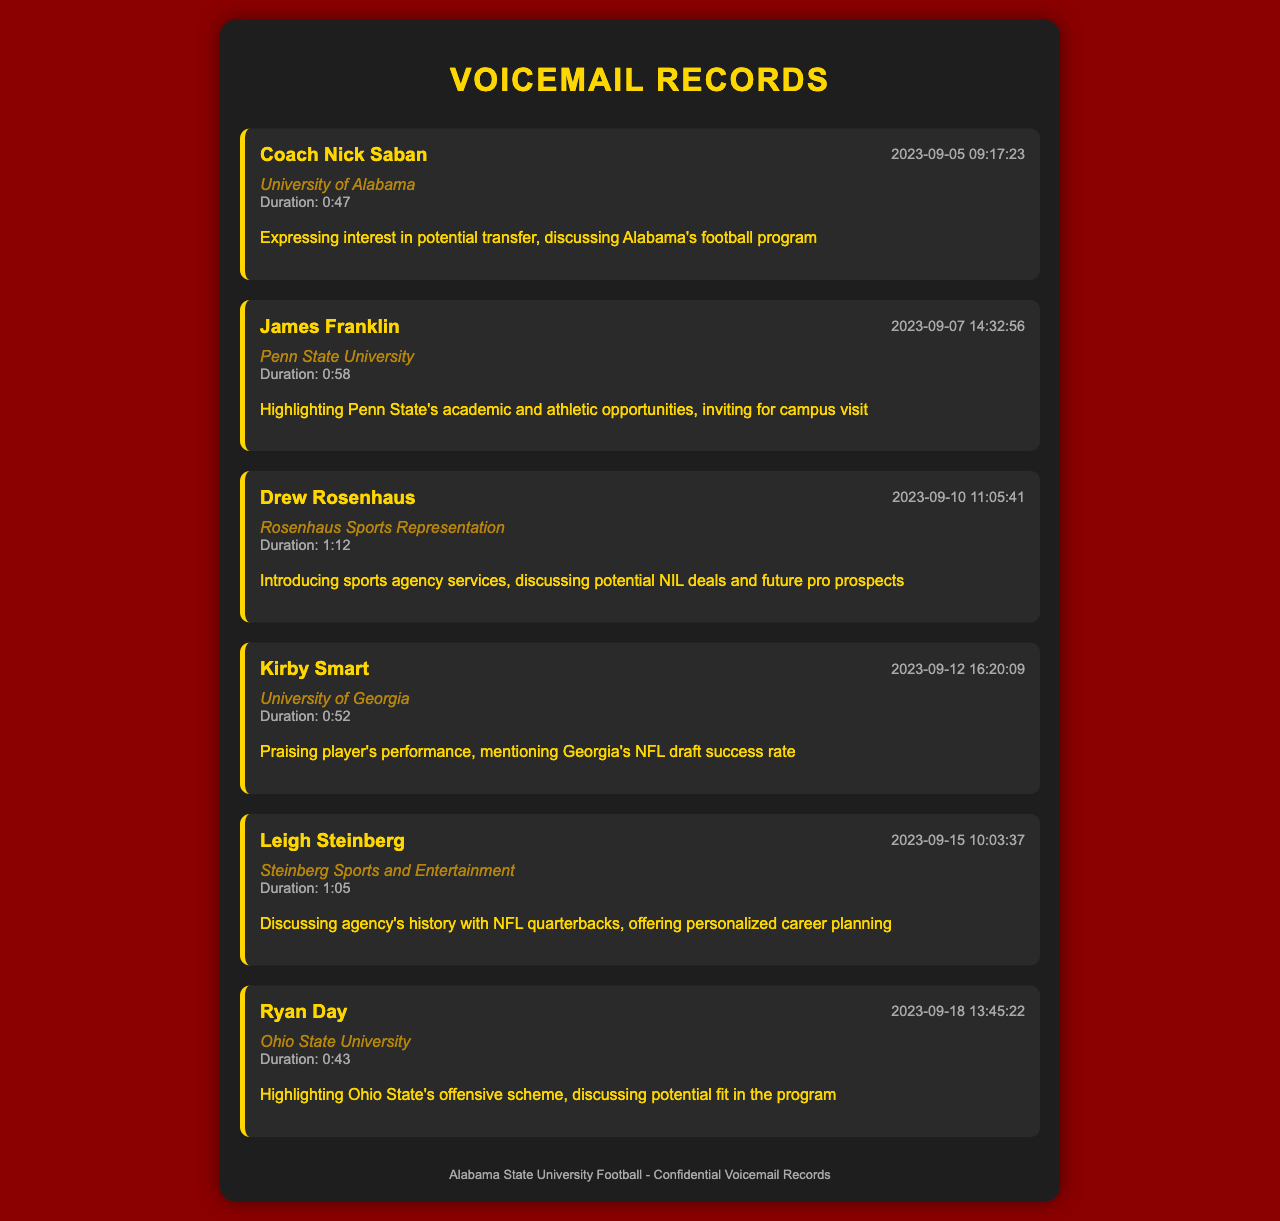What is the timestamp of the voicemail from Coach Nick Saban? The document records the exact time and date of each voicemail message, specifically noting when Coach Nick Saban called.
Answer: 2023-09-05 09:17:23 Who left a voicemail at 2023-09-10? The record includes the names of callers along with their respective timestamps, indicating who made the call on that particular date.
Answer: Drew Rosenhaus What is the duration of the message from Kirby Smart? Each voicemail entry lists its duration; by checking this information, we can determine the length of Kirby Smart's message.
Answer: Duration: 0:52 How many voicemails were received from sports agents? To determine the number of voicemails from sports agents, we can count the entries specifically made by individuals representing sports agencies.
Answer: 2 What organization is associated with Ryan Day? Each voicemail includes the organization that the caller is affiliated with, specifically noted in the details under the caller's name.
Answer: Ohio State University Which caller discussed personalized career planning? The summary of each voicemail provides insights into the main topics discussed, allowing us to identify the caller focused on career planning.
Answer: Leigh Steinberg What is mentioned about Georgia's NFL draft success rate? The summaries often include highlights or key points from the calls, revealing specific topics discussed during the voicemail.
Answer: Mentioning Georgia's NFL draft success rate What was the focus of the voicemail from James Franklin? The document details what each caller highlighted, particularly the points made by James Franklin regarding opportunities.
Answer: Academic and athletic opportunities 